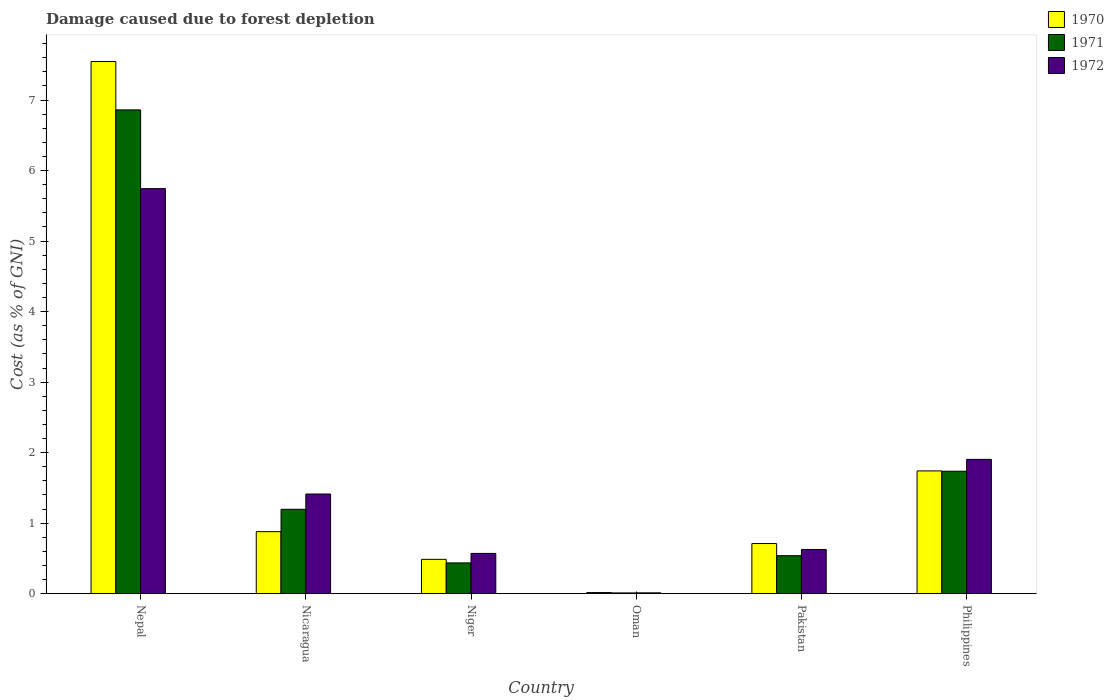Are the number of bars per tick equal to the number of legend labels?
Offer a terse response. Yes. Are the number of bars on each tick of the X-axis equal?
Ensure brevity in your answer.  Yes. How many bars are there on the 6th tick from the left?
Your answer should be very brief. 3. How many bars are there on the 6th tick from the right?
Your answer should be compact. 3. What is the label of the 1st group of bars from the left?
Keep it short and to the point. Nepal. In how many cases, is the number of bars for a given country not equal to the number of legend labels?
Give a very brief answer. 0. What is the cost of damage caused due to forest depletion in 1971 in Nicaragua?
Your answer should be very brief. 1.2. Across all countries, what is the maximum cost of damage caused due to forest depletion in 1972?
Give a very brief answer. 5.74. Across all countries, what is the minimum cost of damage caused due to forest depletion in 1971?
Keep it short and to the point. 0.01. In which country was the cost of damage caused due to forest depletion in 1972 maximum?
Provide a short and direct response. Nepal. In which country was the cost of damage caused due to forest depletion in 1970 minimum?
Offer a very short reply. Oman. What is the total cost of damage caused due to forest depletion in 1972 in the graph?
Keep it short and to the point. 10.27. What is the difference between the cost of damage caused due to forest depletion in 1970 in Nicaragua and that in Oman?
Make the answer very short. 0.86. What is the difference between the cost of damage caused due to forest depletion in 1971 in Oman and the cost of damage caused due to forest depletion in 1970 in Niger?
Provide a succinct answer. -0.48. What is the average cost of damage caused due to forest depletion in 1972 per country?
Give a very brief answer. 1.71. What is the difference between the cost of damage caused due to forest depletion of/in 1972 and cost of damage caused due to forest depletion of/in 1970 in Oman?
Provide a short and direct response. -0. What is the ratio of the cost of damage caused due to forest depletion in 1970 in Nicaragua to that in Oman?
Provide a short and direct response. 56.13. What is the difference between the highest and the second highest cost of damage caused due to forest depletion in 1970?
Keep it short and to the point. -0.86. What is the difference between the highest and the lowest cost of damage caused due to forest depletion in 1970?
Offer a terse response. 7.53. In how many countries, is the cost of damage caused due to forest depletion in 1970 greater than the average cost of damage caused due to forest depletion in 1970 taken over all countries?
Your response must be concise. 1. What does the 3rd bar from the right in Oman represents?
Ensure brevity in your answer.  1970. How many bars are there?
Ensure brevity in your answer.  18. Are all the bars in the graph horizontal?
Ensure brevity in your answer.  No. How many countries are there in the graph?
Give a very brief answer. 6. Does the graph contain any zero values?
Keep it short and to the point. No. Does the graph contain grids?
Offer a very short reply. No. What is the title of the graph?
Offer a terse response. Damage caused due to forest depletion. Does "2008" appear as one of the legend labels in the graph?
Give a very brief answer. No. What is the label or title of the X-axis?
Provide a succinct answer. Country. What is the label or title of the Y-axis?
Give a very brief answer. Cost (as % of GNI). What is the Cost (as % of GNI) in 1970 in Nepal?
Keep it short and to the point. 7.55. What is the Cost (as % of GNI) of 1971 in Nepal?
Your answer should be compact. 6.86. What is the Cost (as % of GNI) of 1972 in Nepal?
Provide a short and direct response. 5.74. What is the Cost (as % of GNI) in 1970 in Nicaragua?
Offer a very short reply. 0.88. What is the Cost (as % of GNI) in 1971 in Nicaragua?
Your response must be concise. 1.2. What is the Cost (as % of GNI) in 1972 in Nicaragua?
Provide a short and direct response. 1.41. What is the Cost (as % of GNI) of 1970 in Niger?
Give a very brief answer. 0.49. What is the Cost (as % of GNI) in 1971 in Niger?
Ensure brevity in your answer.  0.44. What is the Cost (as % of GNI) in 1972 in Niger?
Make the answer very short. 0.57. What is the Cost (as % of GNI) of 1970 in Oman?
Your answer should be compact. 0.02. What is the Cost (as % of GNI) of 1971 in Oman?
Your answer should be very brief. 0.01. What is the Cost (as % of GNI) in 1972 in Oman?
Ensure brevity in your answer.  0.01. What is the Cost (as % of GNI) in 1970 in Pakistan?
Give a very brief answer. 0.71. What is the Cost (as % of GNI) of 1971 in Pakistan?
Ensure brevity in your answer.  0.54. What is the Cost (as % of GNI) in 1972 in Pakistan?
Offer a terse response. 0.63. What is the Cost (as % of GNI) of 1970 in Philippines?
Offer a very short reply. 1.74. What is the Cost (as % of GNI) of 1971 in Philippines?
Keep it short and to the point. 1.74. What is the Cost (as % of GNI) in 1972 in Philippines?
Your response must be concise. 1.9. Across all countries, what is the maximum Cost (as % of GNI) in 1970?
Your answer should be very brief. 7.55. Across all countries, what is the maximum Cost (as % of GNI) in 1971?
Your response must be concise. 6.86. Across all countries, what is the maximum Cost (as % of GNI) in 1972?
Your response must be concise. 5.74. Across all countries, what is the minimum Cost (as % of GNI) of 1970?
Your answer should be compact. 0.02. Across all countries, what is the minimum Cost (as % of GNI) of 1971?
Ensure brevity in your answer.  0.01. Across all countries, what is the minimum Cost (as % of GNI) of 1972?
Your answer should be compact. 0.01. What is the total Cost (as % of GNI) in 1970 in the graph?
Your response must be concise. 11.38. What is the total Cost (as % of GNI) in 1971 in the graph?
Give a very brief answer. 10.78. What is the total Cost (as % of GNI) in 1972 in the graph?
Keep it short and to the point. 10.27. What is the difference between the Cost (as % of GNI) in 1970 in Nepal and that in Nicaragua?
Your answer should be compact. 6.67. What is the difference between the Cost (as % of GNI) of 1971 in Nepal and that in Nicaragua?
Offer a very short reply. 5.66. What is the difference between the Cost (as % of GNI) in 1972 in Nepal and that in Nicaragua?
Provide a succinct answer. 4.33. What is the difference between the Cost (as % of GNI) of 1970 in Nepal and that in Niger?
Your answer should be compact. 7.06. What is the difference between the Cost (as % of GNI) of 1971 in Nepal and that in Niger?
Your answer should be compact. 6.42. What is the difference between the Cost (as % of GNI) in 1972 in Nepal and that in Niger?
Your answer should be very brief. 5.17. What is the difference between the Cost (as % of GNI) in 1970 in Nepal and that in Oman?
Ensure brevity in your answer.  7.53. What is the difference between the Cost (as % of GNI) in 1971 in Nepal and that in Oman?
Provide a short and direct response. 6.85. What is the difference between the Cost (as % of GNI) of 1972 in Nepal and that in Oman?
Make the answer very short. 5.73. What is the difference between the Cost (as % of GNI) of 1970 in Nepal and that in Pakistan?
Your answer should be very brief. 6.84. What is the difference between the Cost (as % of GNI) in 1971 in Nepal and that in Pakistan?
Offer a very short reply. 6.32. What is the difference between the Cost (as % of GNI) of 1972 in Nepal and that in Pakistan?
Make the answer very short. 5.12. What is the difference between the Cost (as % of GNI) of 1970 in Nepal and that in Philippines?
Your answer should be compact. 5.81. What is the difference between the Cost (as % of GNI) of 1971 in Nepal and that in Philippines?
Keep it short and to the point. 5.12. What is the difference between the Cost (as % of GNI) in 1972 in Nepal and that in Philippines?
Give a very brief answer. 3.84. What is the difference between the Cost (as % of GNI) of 1970 in Nicaragua and that in Niger?
Provide a succinct answer. 0.39. What is the difference between the Cost (as % of GNI) in 1971 in Nicaragua and that in Niger?
Offer a terse response. 0.76. What is the difference between the Cost (as % of GNI) of 1972 in Nicaragua and that in Niger?
Your answer should be very brief. 0.84. What is the difference between the Cost (as % of GNI) in 1970 in Nicaragua and that in Oman?
Provide a short and direct response. 0.86. What is the difference between the Cost (as % of GNI) of 1971 in Nicaragua and that in Oman?
Provide a short and direct response. 1.19. What is the difference between the Cost (as % of GNI) of 1972 in Nicaragua and that in Oman?
Make the answer very short. 1.4. What is the difference between the Cost (as % of GNI) of 1970 in Nicaragua and that in Pakistan?
Provide a short and direct response. 0.17. What is the difference between the Cost (as % of GNI) of 1971 in Nicaragua and that in Pakistan?
Keep it short and to the point. 0.66. What is the difference between the Cost (as % of GNI) of 1972 in Nicaragua and that in Pakistan?
Your response must be concise. 0.79. What is the difference between the Cost (as % of GNI) of 1970 in Nicaragua and that in Philippines?
Offer a terse response. -0.86. What is the difference between the Cost (as % of GNI) in 1971 in Nicaragua and that in Philippines?
Ensure brevity in your answer.  -0.54. What is the difference between the Cost (as % of GNI) in 1972 in Nicaragua and that in Philippines?
Provide a short and direct response. -0.49. What is the difference between the Cost (as % of GNI) in 1970 in Niger and that in Oman?
Offer a very short reply. 0.47. What is the difference between the Cost (as % of GNI) of 1971 in Niger and that in Oman?
Give a very brief answer. 0.43. What is the difference between the Cost (as % of GNI) of 1972 in Niger and that in Oman?
Provide a succinct answer. 0.56. What is the difference between the Cost (as % of GNI) in 1970 in Niger and that in Pakistan?
Keep it short and to the point. -0.22. What is the difference between the Cost (as % of GNI) of 1971 in Niger and that in Pakistan?
Provide a succinct answer. -0.1. What is the difference between the Cost (as % of GNI) of 1972 in Niger and that in Pakistan?
Provide a short and direct response. -0.06. What is the difference between the Cost (as % of GNI) in 1970 in Niger and that in Philippines?
Offer a very short reply. -1.25. What is the difference between the Cost (as % of GNI) in 1971 in Niger and that in Philippines?
Your answer should be compact. -1.3. What is the difference between the Cost (as % of GNI) of 1972 in Niger and that in Philippines?
Give a very brief answer. -1.33. What is the difference between the Cost (as % of GNI) of 1970 in Oman and that in Pakistan?
Your response must be concise. -0.7. What is the difference between the Cost (as % of GNI) in 1971 in Oman and that in Pakistan?
Make the answer very short. -0.53. What is the difference between the Cost (as % of GNI) in 1972 in Oman and that in Pakistan?
Provide a succinct answer. -0.62. What is the difference between the Cost (as % of GNI) of 1970 in Oman and that in Philippines?
Offer a very short reply. -1.72. What is the difference between the Cost (as % of GNI) in 1971 in Oman and that in Philippines?
Give a very brief answer. -1.73. What is the difference between the Cost (as % of GNI) of 1972 in Oman and that in Philippines?
Make the answer very short. -1.89. What is the difference between the Cost (as % of GNI) of 1970 in Pakistan and that in Philippines?
Your answer should be compact. -1.03. What is the difference between the Cost (as % of GNI) of 1971 in Pakistan and that in Philippines?
Your answer should be compact. -1.2. What is the difference between the Cost (as % of GNI) in 1972 in Pakistan and that in Philippines?
Your answer should be very brief. -1.28. What is the difference between the Cost (as % of GNI) in 1970 in Nepal and the Cost (as % of GNI) in 1971 in Nicaragua?
Offer a terse response. 6.35. What is the difference between the Cost (as % of GNI) of 1970 in Nepal and the Cost (as % of GNI) of 1972 in Nicaragua?
Give a very brief answer. 6.13. What is the difference between the Cost (as % of GNI) of 1971 in Nepal and the Cost (as % of GNI) of 1972 in Nicaragua?
Keep it short and to the point. 5.45. What is the difference between the Cost (as % of GNI) of 1970 in Nepal and the Cost (as % of GNI) of 1971 in Niger?
Keep it short and to the point. 7.11. What is the difference between the Cost (as % of GNI) of 1970 in Nepal and the Cost (as % of GNI) of 1972 in Niger?
Your response must be concise. 6.98. What is the difference between the Cost (as % of GNI) in 1971 in Nepal and the Cost (as % of GNI) in 1972 in Niger?
Offer a very short reply. 6.29. What is the difference between the Cost (as % of GNI) in 1970 in Nepal and the Cost (as % of GNI) in 1971 in Oman?
Ensure brevity in your answer.  7.54. What is the difference between the Cost (as % of GNI) of 1970 in Nepal and the Cost (as % of GNI) of 1972 in Oman?
Ensure brevity in your answer.  7.54. What is the difference between the Cost (as % of GNI) of 1971 in Nepal and the Cost (as % of GNI) of 1972 in Oman?
Provide a short and direct response. 6.85. What is the difference between the Cost (as % of GNI) in 1970 in Nepal and the Cost (as % of GNI) in 1971 in Pakistan?
Provide a succinct answer. 7.01. What is the difference between the Cost (as % of GNI) in 1970 in Nepal and the Cost (as % of GNI) in 1972 in Pakistan?
Make the answer very short. 6.92. What is the difference between the Cost (as % of GNI) in 1971 in Nepal and the Cost (as % of GNI) in 1972 in Pakistan?
Keep it short and to the point. 6.23. What is the difference between the Cost (as % of GNI) in 1970 in Nepal and the Cost (as % of GNI) in 1971 in Philippines?
Your answer should be compact. 5.81. What is the difference between the Cost (as % of GNI) in 1970 in Nepal and the Cost (as % of GNI) in 1972 in Philippines?
Provide a short and direct response. 5.64. What is the difference between the Cost (as % of GNI) of 1971 in Nepal and the Cost (as % of GNI) of 1972 in Philippines?
Make the answer very short. 4.96. What is the difference between the Cost (as % of GNI) of 1970 in Nicaragua and the Cost (as % of GNI) of 1971 in Niger?
Your response must be concise. 0.44. What is the difference between the Cost (as % of GNI) in 1970 in Nicaragua and the Cost (as % of GNI) in 1972 in Niger?
Your response must be concise. 0.31. What is the difference between the Cost (as % of GNI) in 1971 in Nicaragua and the Cost (as % of GNI) in 1972 in Niger?
Give a very brief answer. 0.63. What is the difference between the Cost (as % of GNI) in 1970 in Nicaragua and the Cost (as % of GNI) in 1971 in Oman?
Offer a terse response. 0.87. What is the difference between the Cost (as % of GNI) in 1970 in Nicaragua and the Cost (as % of GNI) in 1972 in Oman?
Ensure brevity in your answer.  0.87. What is the difference between the Cost (as % of GNI) of 1971 in Nicaragua and the Cost (as % of GNI) of 1972 in Oman?
Offer a very short reply. 1.18. What is the difference between the Cost (as % of GNI) of 1970 in Nicaragua and the Cost (as % of GNI) of 1971 in Pakistan?
Your response must be concise. 0.34. What is the difference between the Cost (as % of GNI) of 1970 in Nicaragua and the Cost (as % of GNI) of 1972 in Pakistan?
Provide a succinct answer. 0.25. What is the difference between the Cost (as % of GNI) in 1971 in Nicaragua and the Cost (as % of GNI) in 1972 in Pakistan?
Your response must be concise. 0.57. What is the difference between the Cost (as % of GNI) of 1970 in Nicaragua and the Cost (as % of GNI) of 1971 in Philippines?
Offer a terse response. -0.86. What is the difference between the Cost (as % of GNI) in 1970 in Nicaragua and the Cost (as % of GNI) in 1972 in Philippines?
Provide a short and direct response. -1.03. What is the difference between the Cost (as % of GNI) of 1971 in Nicaragua and the Cost (as % of GNI) of 1972 in Philippines?
Your answer should be very brief. -0.71. What is the difference between the Cost (as % of GNI) in 1970 in Niger and the Cost (as % of GNI) in 1971 in Oman?
Keep it short and to the point. 0.48. What is the difference between the Cost (as % of GNI) in 1970 in Niger and the Cost (as % of GNI) in 1972 in Oman?
Provide a succinct answer. 0.48. What is the difference between the Cost (as % of GNI) of 1971 in Niger and the Cost (as % of GNI) of 1972 in Oman?
Provide a short and direct response. 0.42. What is the difference between the Cost (as % of GNI) in 1970 in Niger and the Cost (as % of GNI) in 1971 in Pakistan?
Keep it short and to the point. -0.05. What is the difference between the Cost (as % of GNI) of 1970 in Niger and the Cost (as % of GNI) of 1972 in Pakistan?
Make the answer very short. -0.14. What is the difference between the Cost (as % of GNI) of 1971 in Niger and the Cost (as % of GNI) of 1972 in Pakistan?
Offer a terse response. -0.19. What is the difference between the Cost (as % of GNI) in 1970 in Niger and the Cost (as % of GNI) in 1971 in Philippines?
Make the answer very short. -1.25. What is the difference between the Cost (as % of GNI) of 1970 in Niger and the Cost (as % of GNI) of 1972 in Philippines?
Provide a short and direct response. -1.42. What is the difference between the Cost (as % of GNI) in 1971 in Niger and the Cost (as % of GNI) in 1972 in Philippines?
Your answer should be compact. -1.47. What is the difference between the Cost (as % of GNI) of 1970 in Oman and the Cost (as % of GNI) of 1971 in Pakistan?
Your response must be concise. -0.52. What is the difference between the Cost (as % of GNI) in 1970 in Oman and the Cost (as % of GNI) in 1972 in Pakistan?
Make the answer very short. -0.61. What is the difference between the Cost (as % of GNI) in 1971 in Oman and the Cost (as % of GNI) in 1972 in Pakistan?
Offer a terse response. -0.62. What is the difference between the Cost (as % of GNI) in 1970 in Oman and the Cost (as % of GNI) in 1971 in Philippines?
Offer a terse response. -1.72. What is the difference between the Cost (as % of GNI) of 1970 in Oman and the Cost (as % of GNI) of 1972 in Philippines?
Make the answer very short. -1.89. What is the difference between the Cost (as % of GNI) in 1971 in Oman and the Cost (as % of GNI) in 1972 in Philippines?
Give a very brief answer. -1.89. What is the difference between the Cost (as % of GNI) of 1970 in Pakistan and the Cost (as % of GNI) of 1971 in Philippines?
Your answer should be very brief. -1.03. What is the difference between the Cost (as % of GNI) of 1970 in Pakistan and the Cost (as % of GNI) of 1972 in Philippines?
Provide a short and direct response. -1.19. What is the difference between the Cost (as % of GNI) in 1971 in Pakistan and the Cost (as % of GNI) in 1972 in Philippines?
Provide a short and direct response. -1.37. What is the average Cost (as % of GNI) in 1970 per country?
Give a very brief answer. 1.9. What is the average Cost (as % of GNI) of 1971 per country?
Give a very brief answer. 1.8. What is the average Cost (as % of GNI) in 1972 per country?
Offer a terse response. 1.71. What is the difference between the Cost (as % of GNI) in 1970 and Cost (as % of GNI) in 1971 in Nepal?
Provide a short and direct response. 0.69. What is the difference between the Cost (as % of GNI) of 1970 and Cost (as % of GNI) of 1972 in Nepal?
Make the answer very short. 1.8. What is the difference between the Cost (as % of GNI) of 1971 and Cost (as % of GNI) of 1972 in Nepal?
Your answer should be compact. 1.12. What is the difference between the Cost (as % of GNI) of 1970 and Cost (as % of GNI) of 1971 in Nicaragua?
Offer a very short reply. -0.32. What is the difference between the Cost (as % of GNI) in 1970 and Cost (as % of GNI) in 1972 in Nicaragua?
Offer a very short reply. -0.53. What is the difference between the Cost (as % of GNI) in 1971 and Cost (as % of GNI) in 1972 in Nicaragua?
Ensure brevity in your answer.  -0.22. What is the difference between the Cost (as % of GNI) of 1970 and Cost (as % of GNI) of 1971 in Niger?
Ensure brevity in your answer.  0.05. What is the difference between the Cost (as % of GNI) of 1970 and Cost (as % of GNI) of 1972 in Niger?
Keep it short and to the point. -0.08. What is the difference between the Cost (as % of GNI) of 1971 and Cost (as % of GNI) of 1972 in Niger?
Your answer should be compact. -0.13. What is the difference between the Cost (as % of GNI) of 1970 and Cost (as % of GNI) of 1971 in Oman?
Your response must be concise. 0.01. What is the difference between the Cost (as % of GNI) in 1970 and Cost (as % of GNI) in 1972 in Oman?
Your answer should be very brief. 0. What is the difference between the Cost (as % of GNI) in 1971 and Cost (as % of GNI) in 1972 in Oman?
Keep it short and to the point. -0. What is the difference between the Cost (as % of GNI) of 1970 and Cost (as % of GNI) of 1971 in Pakistan?
Give a very brief answer. 0.17. What is the difference between the Cost (as % of GNI) of 1970 and Cost (as % of GNI) of 1972 in Pakistan?
Keep it short and to the point. 0.08. What is the difference between the Cost (as % of GNI) of 1971 and Cost (as % of GNI) of 1972 in Pakistan?
Offer a terse response. -0.09. What is the difference between the Cost (as % of GNI) in 1970 and Cost (as % of GNI) in 1971 in Philippines?
Provide a short and direct response. 0. What is the difference between the Cost (as % of GNI) of 1970 and Cost (as % of GNI) of 1972 in Philippines?
Keep it short and to the point. -0.16. What is the difference between the Cost (as % of GNI) of 1971 and Cost (as % of GNI) of 1972 in Philippines?
Your response must be concise. -0.17. What is the ratio of the Cost (as % of GNI) in 1970 in Nepal to that in Nicaragua?
Give a very brief answer. 8.58. What is the ratio of the Cost (as % of GNI) in 1971 in Nepal to that in Nicaragua?
Keep it short and to the point. 5.73. What is the ratio of the Cost (as % of GNI) in 1972 in Nepal to that in Nicaragua?
Make the answer very short. 4.06. What is the ratio of the Cost (as % of GNI) of 1970 in Nepal to that in Niger?
Provide a short and direct response. 15.5. What is the ratio of the Cost (as % of GNI) in 1971 in Nepal to that in Niger?
Make the answer very short. 15.73. What is the ratio of the Cost (as % of GNI) in 1972 in Nepal to that in Niger?
Give a very brief answer. 10.06. What is the ratio of the Cost (as % of GNI) of 1970 in Nepal to that in Oman?
Give a very brief answer. 481.77. What is the ratio of the Cost (as % of GNI) in 1971 in Nepal to that in Oman?
Provide a succinct answer. 654.02. What is the ratio of the Cost (as % of GNI) in 1972 in Nepal to that in Oman?
Provide a succinct answer. 494.94. What is the ratio of the Cost (as % of GNI) of 1970 in Nepal to that in Pakistan?
Make the answer very short. 10.62. What is the ratio of the Cost (as % of GNI) of 1971 in Nepal to that in Pakistan?
Your answer should be compact. 12.74. What is the ratio of the Cost (as % of GNI) in 1972 in Nepal to that in Pakistan?
Ensure brevity in your answer.  9.16. What is the ratio of the Cost (as % of GNI) of 1970 in Nepal to that in Philippines?
Keep it short and to the point. 4.34. What is the ratio of the Cost (as % of GNI) of 1971 in Nepal to that in Philippines?
Provide a succinct answer. 3.95. What is the ratio of the Cost (as % of GNI) of 1972 in Nepal to that in Philippines?
Offer a terse response. 3.02. What is the ratio of the Cost (as % of GNI) in 1970 in Nicaragua to that in Niger?
Keep it short and to the point. 1.81. What is the ratio of the Cost (as % of GNI) in 1971 in Nicaragua to that in Niger?
Give a very brief answer. 2.74. What is the ratio of the Cost (as % of GNI) in 1972 in Nicaragua to that in Niger?
Your answer should be compact. 2.48. What is the ratio of the Cost (as % of GNI) in 1970 in Nicaragua to that in Oman?
Give a very brief answer. 56.13. What is the ratio of the Cost (as % of GNI) in 1971 in Nicaragua to that in Oman?
Your answer should be compact. 114.06. What is the ratio of the Cost (as % of GNI) in 1972 in Nicaragua to that in Oman?
Make the answer very short. 121.77. What is the ratio of the Cost (as % of GNI) in 1970 in Nicaragua to that in Pakistan?
Your response must be concise. 1.24. What is the ratio of the Cost (as % of GNI) of 1971 in Nicaragua to that in Pakistan?
Make the answer very short. 2.22. What is the ratio of the Cost (as % of GNI) in 1972 in Nicaragua to that in Pakistan?
Your response must be concise. 2.25. What is the ratio of the Cost (as % of GNI) of 1970 in Nicaragua to that in Philippines?
Offer a very short reply. 0.51. What is the ratio of the Cost (as % of GNI) in 1971 in Nicaragua to that in Philippines?
Provide a short and direct response. 0.69. What is the ratio of the Cost (as % of GNI) of 1972 in Nicaragua to that in Philippines?
Offer a terse response. 0.74. What is the ratio of the Cost (as % of GNI) in 1970 in Niger to that in Oman?
Your answer should be compact. 31.07. What is the ratio of the Cost (as % of GNI) of 1971 in Niger to that in Oman?
Your answer should be compact. 41.58. What is the ratio of the Cost (as % of GNI) in 1972 in Niger to that in Oman?
Offer a terse response. 49.18. What is the ratio of the Cost (as % of GNI) of 1970 in Niger to that in Pakistan?
Your response must be concise. 0.68. What is the ratio of the Cost (as % of GNI) of 1971 in Niger to that in Pakistan?
Make the answer very short. 0.81. What is the ratio of the Cost (as % of GNI) in 1972 in Niger to that in Pakistan?
Your answer should be very brief. 0.91. What is the ratio of the Cost (as % of GNI) of 1970 in Niger to that in Philippines?
Your answer should be very brief. 0.28. What is the ratio of the Cost (as % of GNI) in 1971 in Niger to that in Philippines?
Keep it short and to the point. 0.25. What is the ratio of the Cost (as % of GNI) in 1972 in Niger to that in Philippines?
Your answer should be very brief. 0.3. What is the ratio of the Cost (as % of GNI) of 1970 in Oman to that in Pakistan?
Provide a short and direct response. 0.02. What is the ratio of the Cost (as % of GNI) of 1971 in Oman to that in Pakistan?
Your answer should be compact. 0.02. What is the ratio of the Cost (as % of GNI) of 1972 in Oman to that in Pakistan?
Your answer should be compact. 0.02. What is the ratio of the Cost (as % of GNI) of 1970 in Oman to that in Philippines?
Make the answer very short. 0.01. What is the ratio of the Cost (as % of GNI) of 1971 in Oman to that in Philippines?
Keep it short and to the point. 0.01. What is the ratio of the Cost (as % of GNI) in 1972 in Oman to that in Philippines?
Offer a very short reply. 0.01. What is the ratio of the Cost (as % of GNI) in 1970 in Pakistan to that in Philippines?
Offer a terse response. 0.41. What is the ratio of the Cost (as % of GNI) of 1971 in Pakistan to that in Philippines?
Offer a terse response. 0.31. What is the ratio of the Cost (as % of GNI) of 1972 in Pakistan to that in Philippines?
Your response must be concise. 0.33. What is the difference between the highest and the second highest Cost (as % of GNI) in 1970?
Ensure brevity in your answer.  5.81. What is the difference between the highest and the second highest Cost (as % of GNI) of 1971?
Keep it short and to the point. 5.12. What is the difference between the highest and the second highest Cost (as % of GNI) of 1972?
Your answer should be compact. 3.84. What is the difference between the highest and the lowest Cost (as % of GNI) in 1970?
Offer a terse response. 7.53. What is the difference between the highest and the lowest Cost (as % of GNI) of 1971?
Make the answer very short. 6.85. What is the difference between the highest and the lowest Cost (as % of GNI) in 1972?
Your answer should be compact. 5.73. 